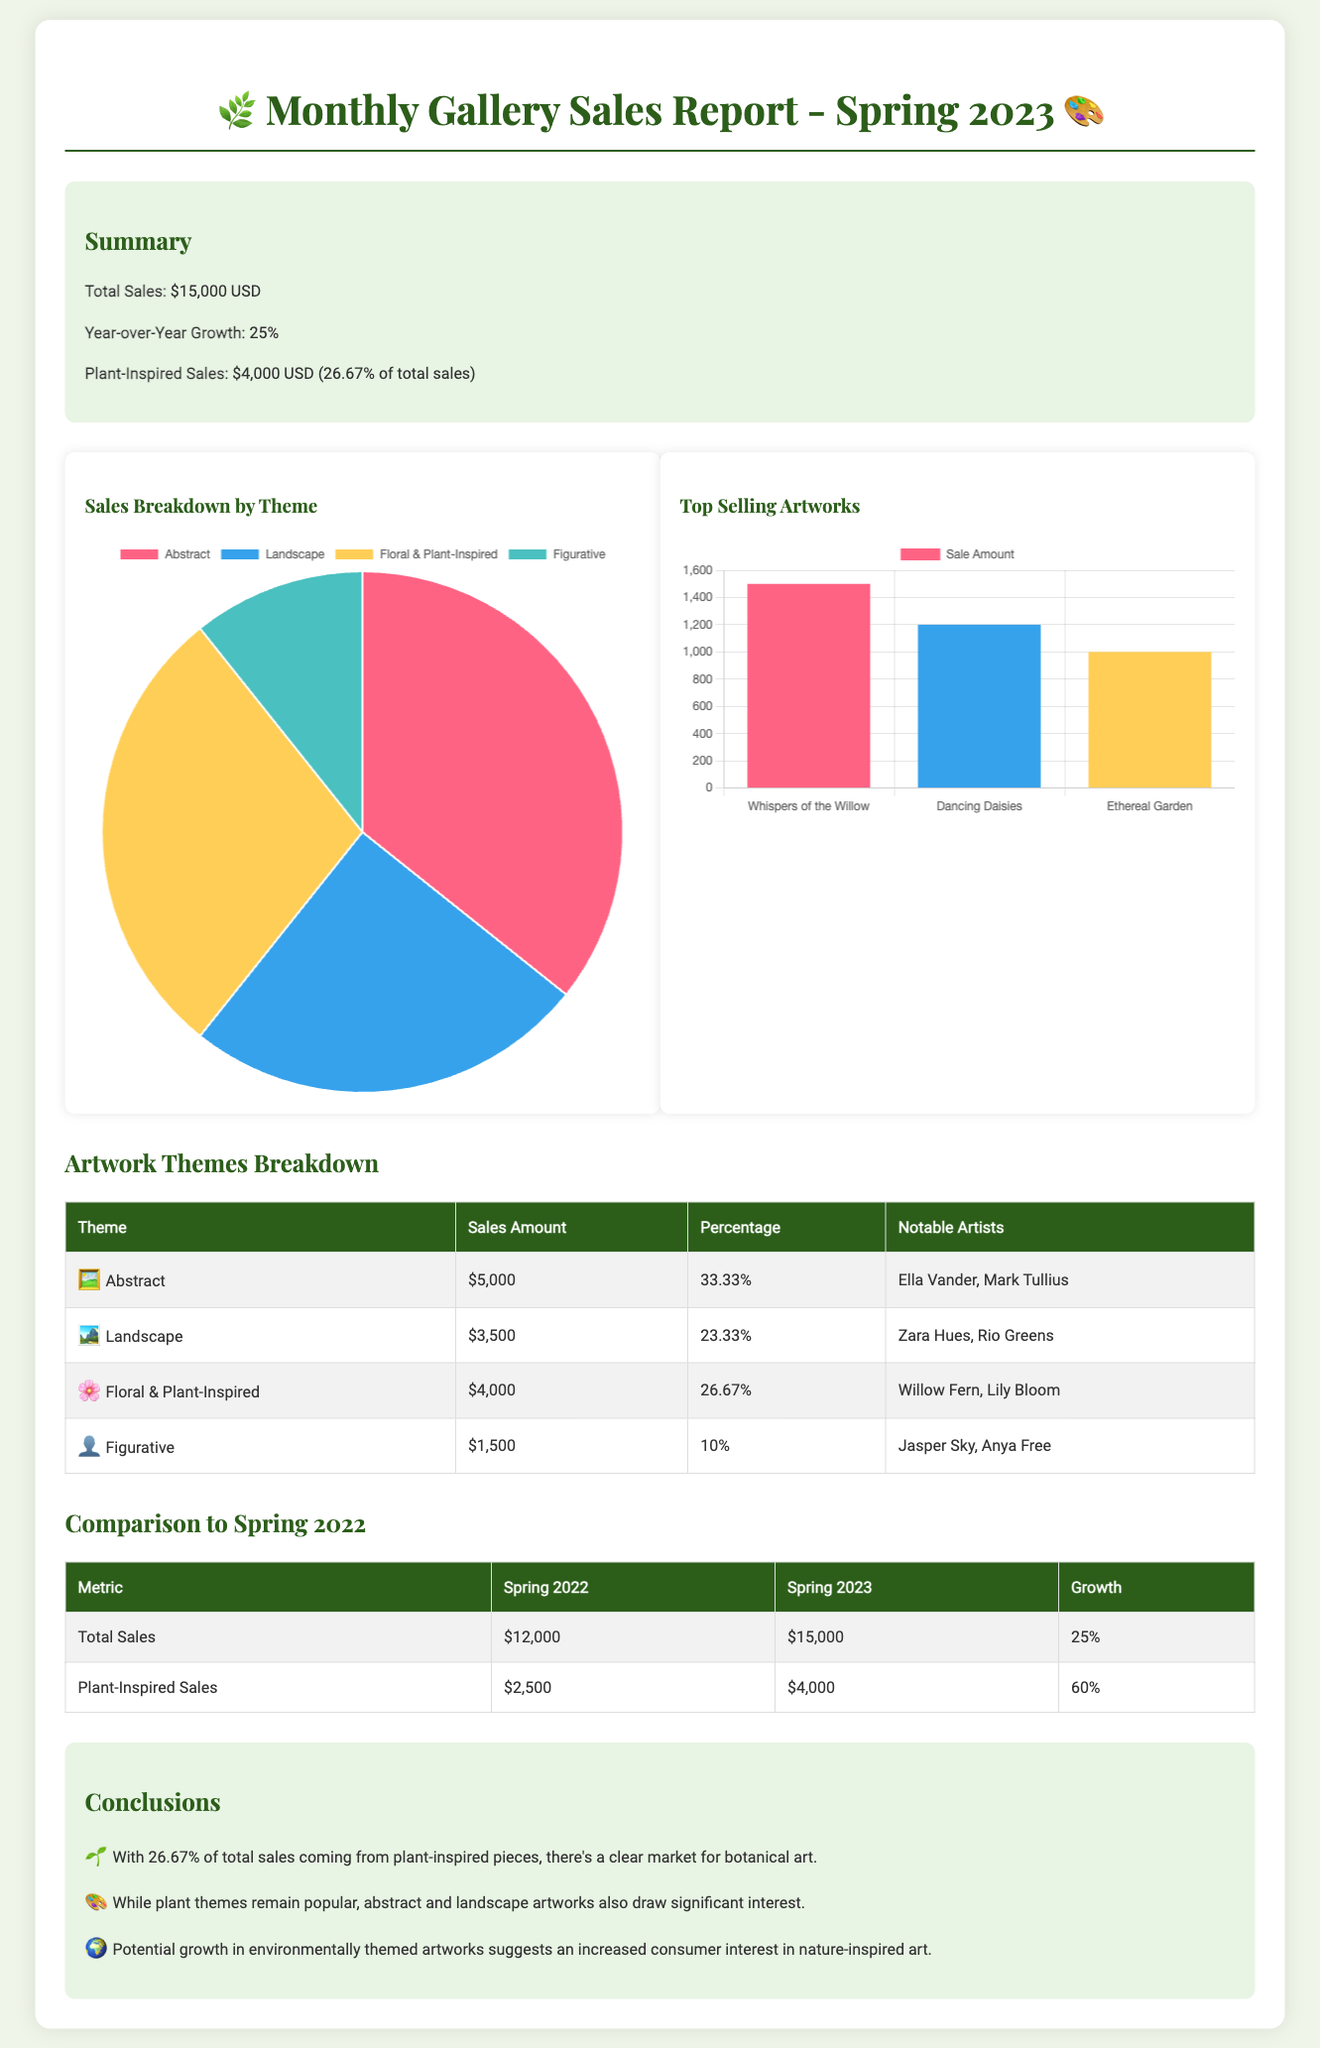What was the total sales amount for Spring 2023? The total sales amount is stated in the summary section of the document.
Answer: $15,000 USD What percentage of total sales did plant-inspired pieces contribute? The percentage of total sales from plant-inspired pieces is highlighted in the summary.
Answer: 26.67% Who are the notable artists for the Floral & Plant-Inspired theme? The notable artists related to the Floral & Plant-Inspired theme are mentioned in the artwork themes breakdown table.
Answer: Willow Fern, Lily Bloom What was the growth percentage from Spring 2022 to Spring 2023? The growth percentage comparing the sales figures for the two years is provided in the comparison table.
Answer: 25% How much did plant-inspired sales increase from Spring 2022 to Spring 2023? The increase in plant-inspired sales is calculated by comparing the figures for both years in the comparison section.
Answer: 60% Which theme had the highest sales? The theme with the highest sales can be determined by examining the artwork themes breakdown table.
Answer: Abstract What is the sales amount for the Figurative theme? The sales amount for the Figurative theme is listed in the artwork themes breakdown table.
Answer: $1,500 What is the total sales for Spring 2022? The total sales for Spring 2022 can be found in the comparison table in the document.
Answer: $12,000 What is the focus of the conclusions section? The conclusions section summarizes the overall findings and insights from the sales report.
Answer: Market for botanical art 